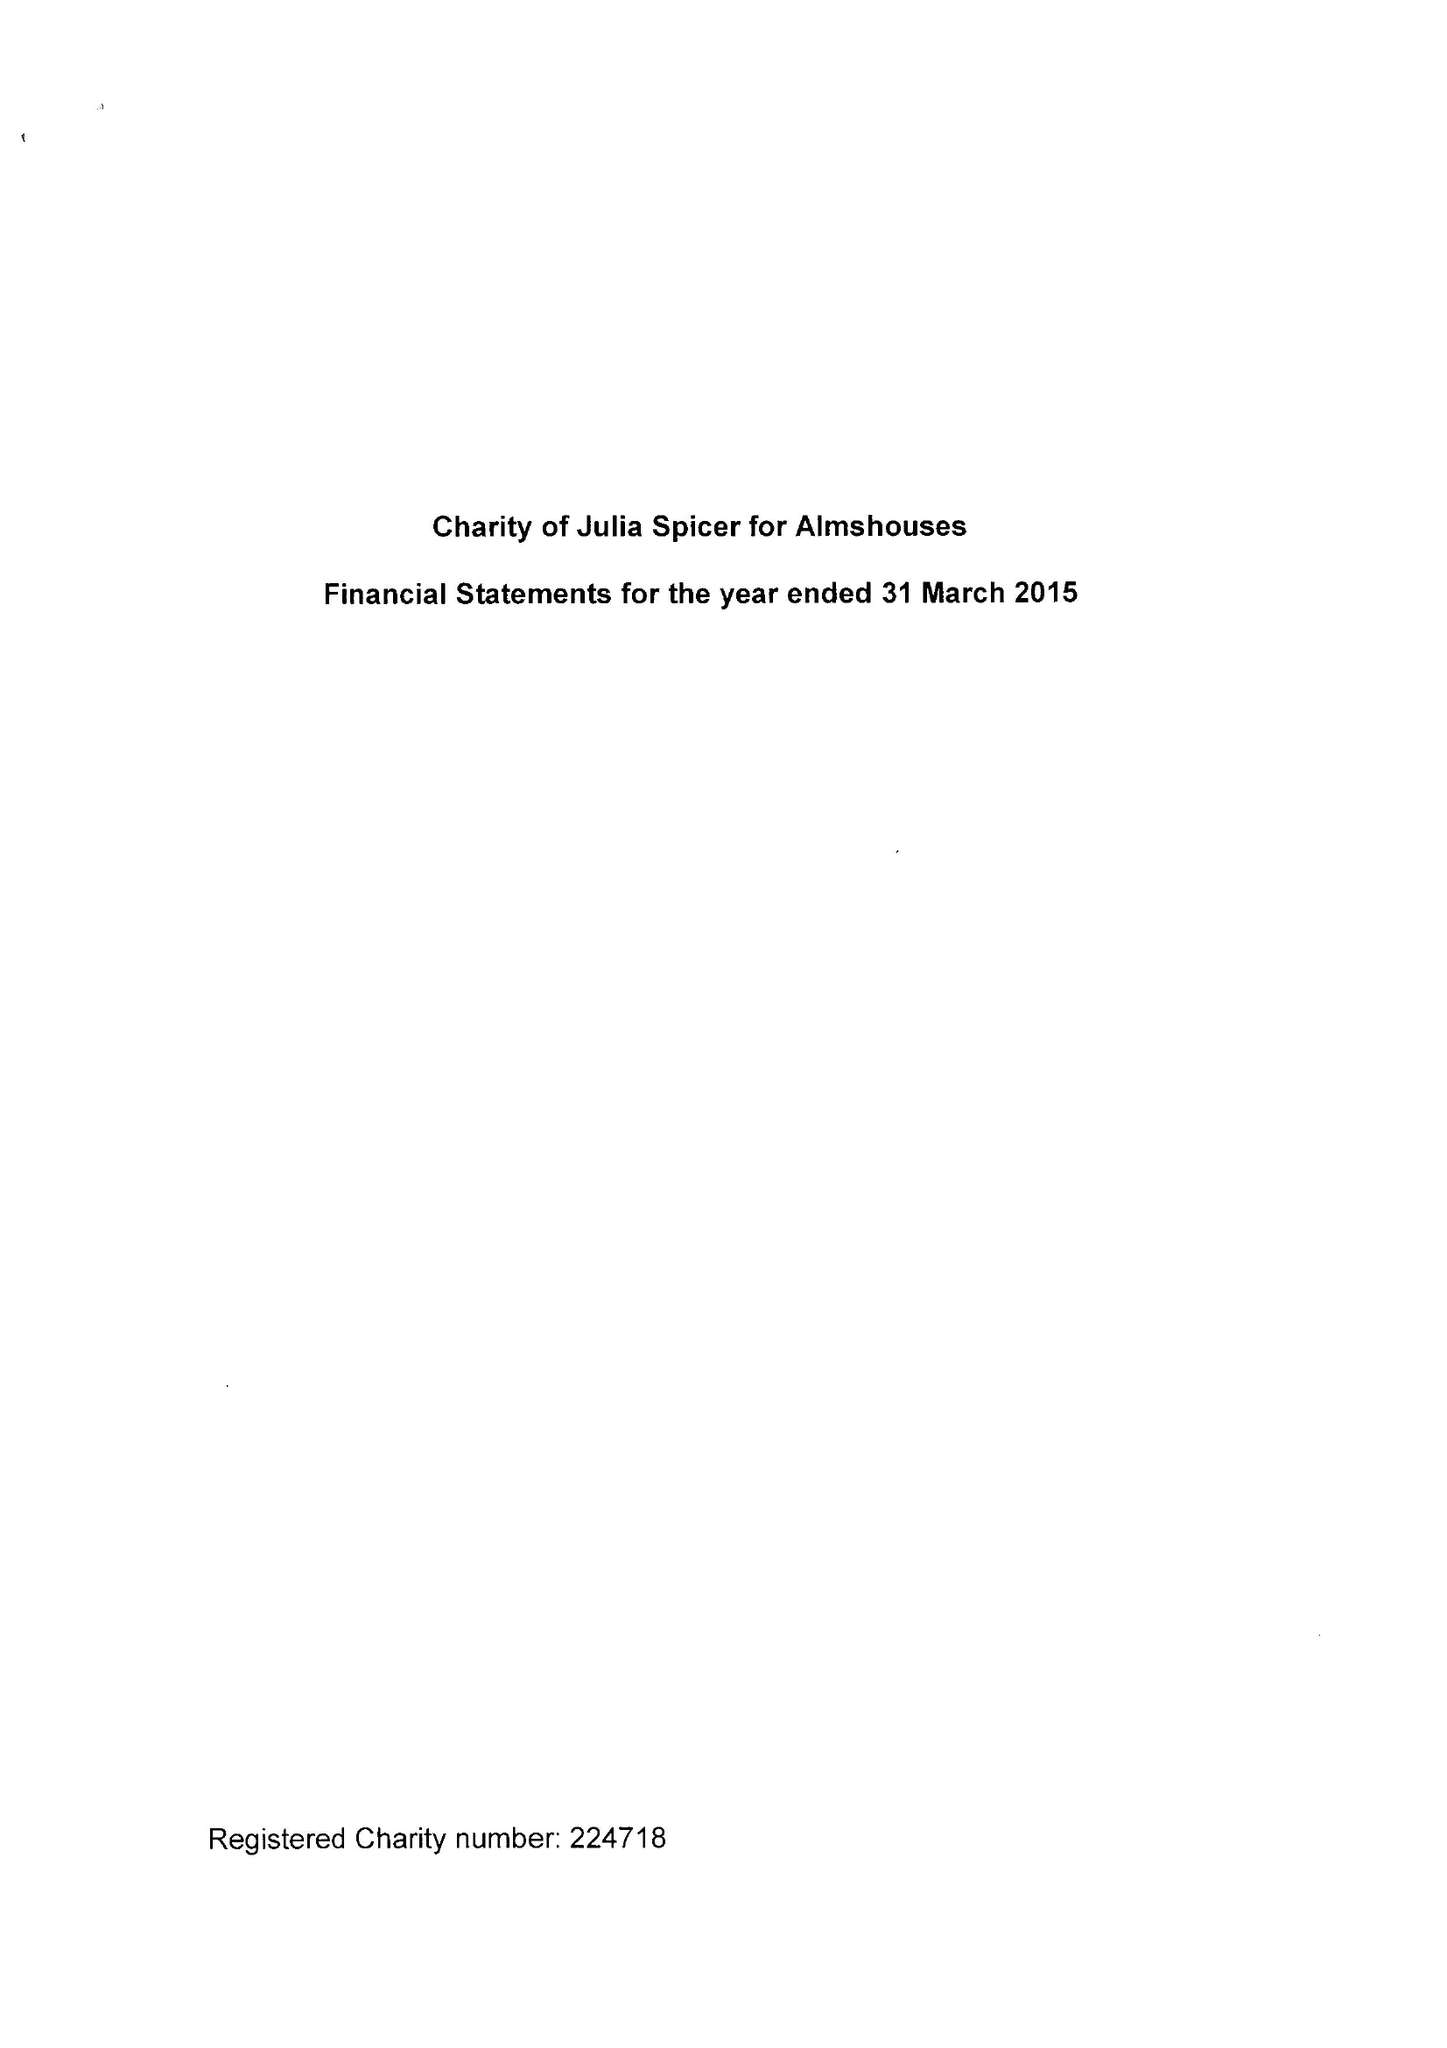What is the value for the charity_number?
Answer the question using a single word or phrase. 224718 